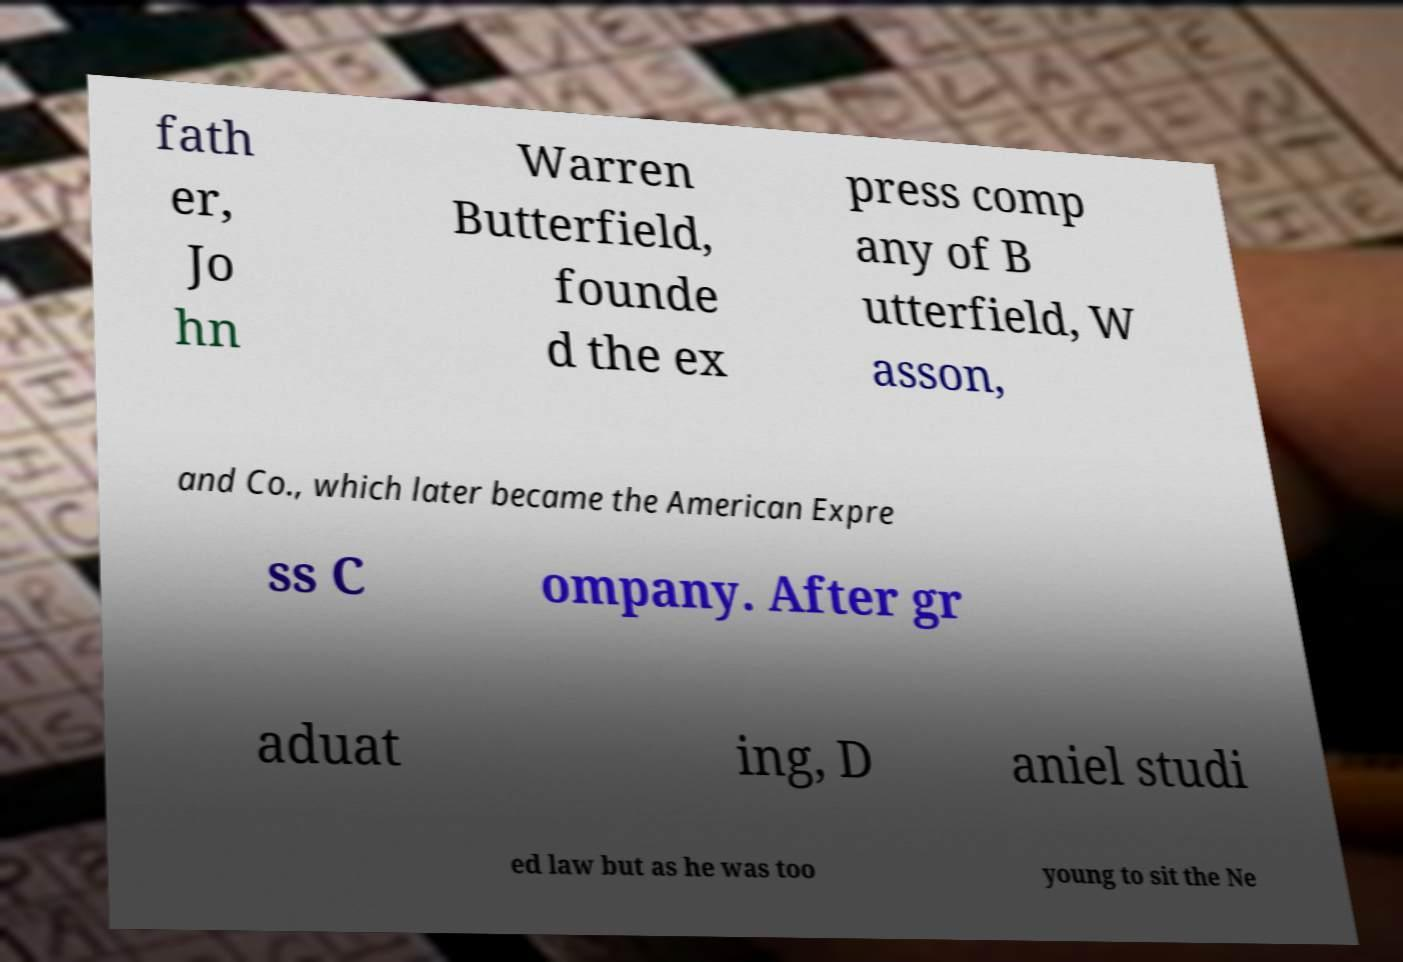Can you read and provide the text displayed in the image?This photo seems to have some interesting text. Can you extract and type it out for me? fath er, Jo hn Warren Butterfield, founde d the ex press comp any of B utterfield, W asson, and Co., which later became the American Expre ss C ompany. After gr aduat ing, D aniel studi ed law but as he was too young to sit the Ne 